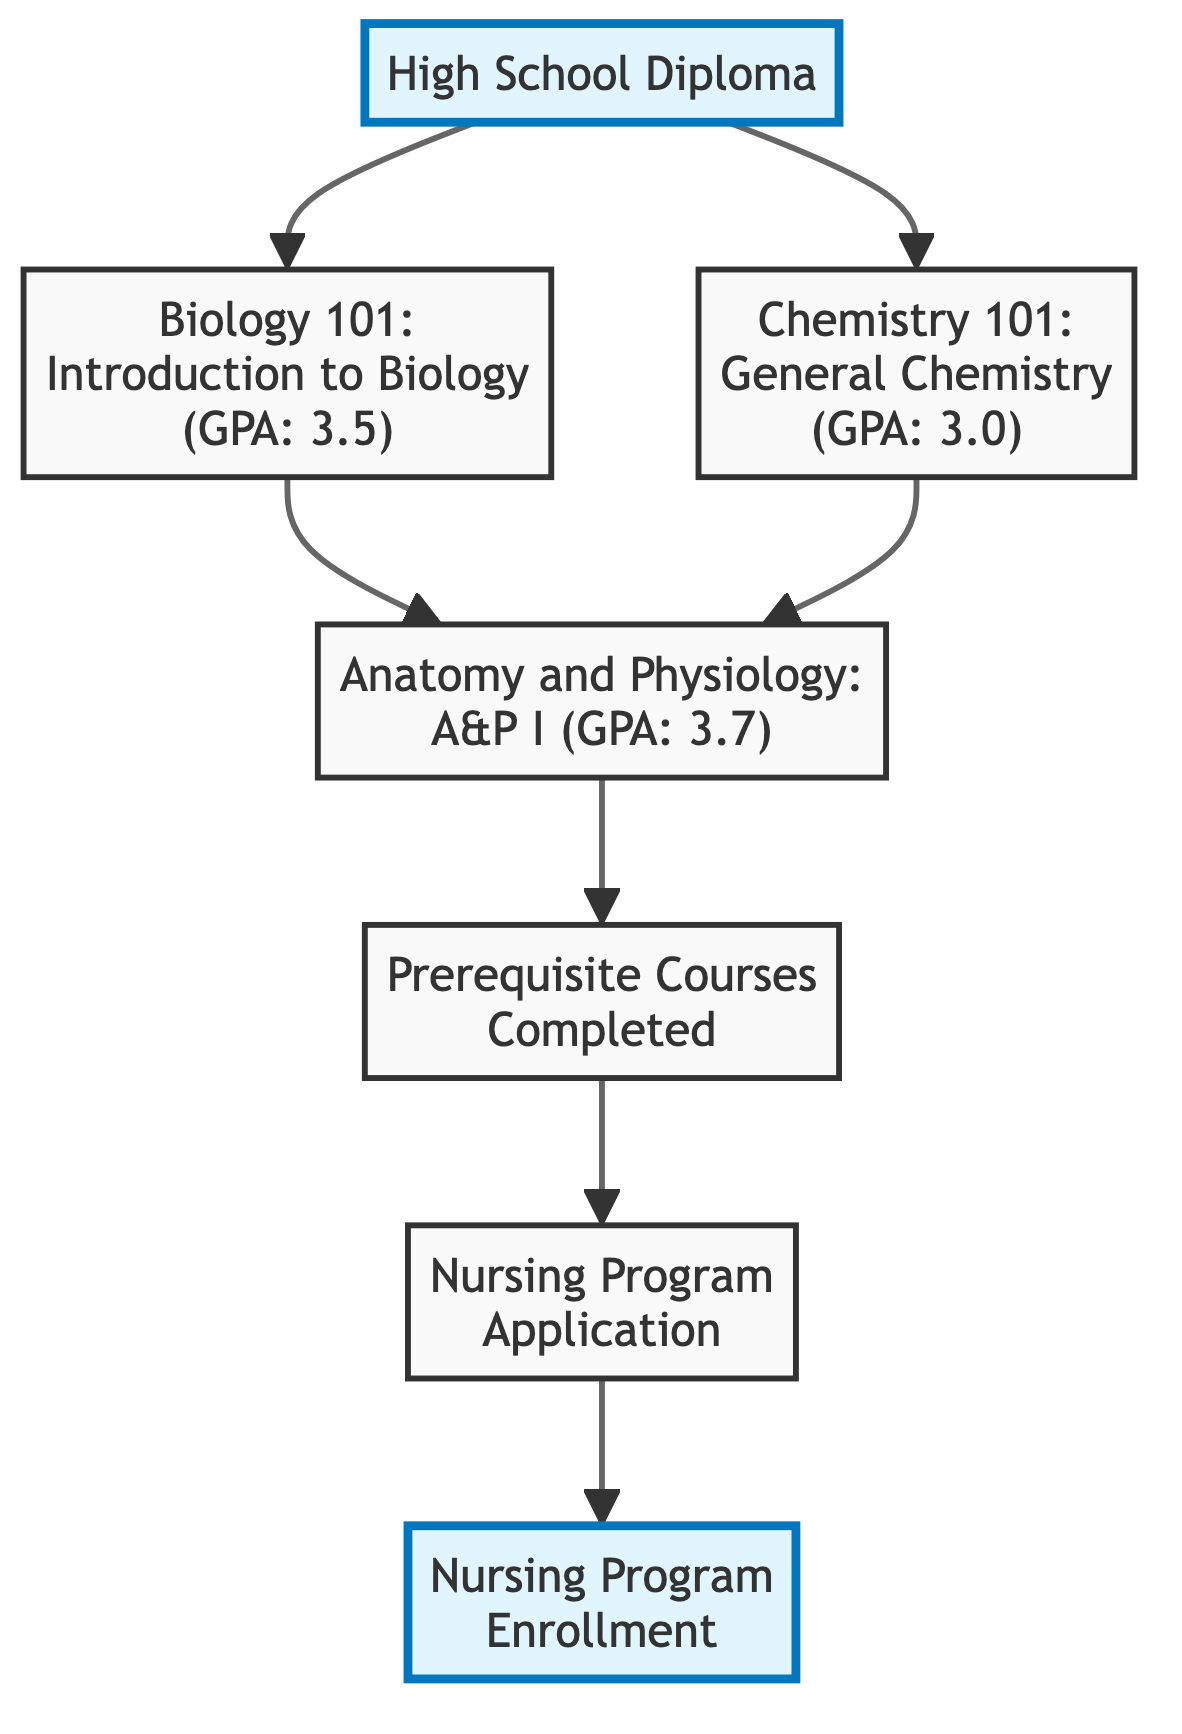What is the GPA for Biology 101? The diagram indicates the GPA for Biology 101 as 3.5, which is stated directly in the node description.
Answer: 3.5 What courses are prerequisites for Anatomy and Physiology? The edges leading to the Anatomy and Physiology node show that both Biology 101 and Chemistry 101 are prerequisites, specified by the arrows from those nodes to Anatomy and Physiology.
Answer: Biology 101, Chemistry 101 How many total nodes are in the diagram? By counting the nodes listed in the input data, there are 7 nodes in total: High School Diploma, Biology 101, Chemistry 101, Anatomy and Physiology, Nursing Prerequisites Completed, Nursing Application, and Nursing Program.
Answer: 7 What is the GPA for Anatomy and Physiology? The GPA for Anatomy and Physiology is explicitly shown in its node description as 3.7.
Answer: 3.7 Which node comes immediately after completing the prerequisite courses? The Nursing Application node is the next step after Nursing Prerequisites Completed, as indicated by the directed edge connecting them in the diagram.
Answer: Nursing Application How many courses must be completed before applying to the Nursing Program? The diagram shows that a total of three courses (Biology 101, Chemistry 101, and Anatomy and Physiology) must be completed before moving to the Nursing Application step after completing prerequisites.
Answer: Three courses What is the relationship between Chemistry 101 and Anatomy and Physiology? The diagram shows a directed edge from Chemistry 101 to Anatomy and Physiology, indicating that Chemistry 101 is a prerequisite course necessary for Anatomy and Physiology.
Answer: Prerequisite relationship What is the final node in the academic journey? The Nursing Program Enrollment is the final node in the journey, as it is the last step connected by an edge from the Nursing Application node.
Answer: Nursing Program Enrollment Which course has the lowest GPA and what is that GPA? Chemistry 101 has the lowest GPA among the courses listed, which is stated as 3.0 in the node description.
Answer: 3.0 